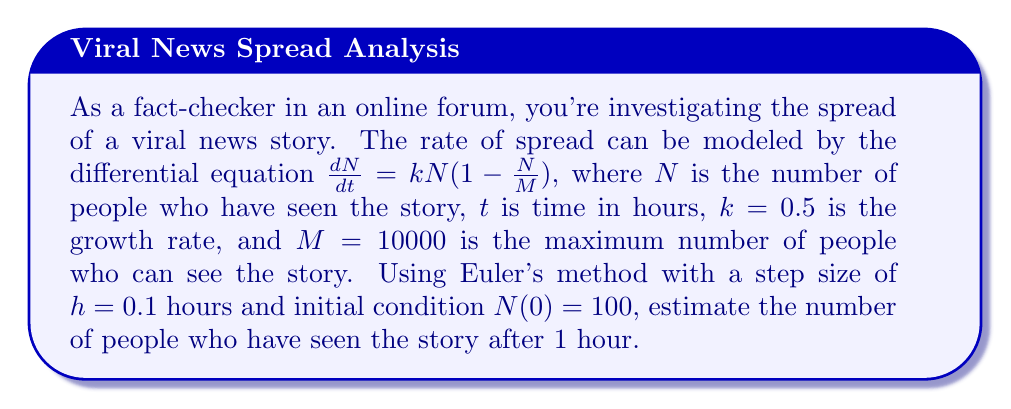Solve this math problem. To solve this problem using Euler's method, we follow these steps:

1) Euler's method is given by the formula:
   $$N_{i+1} = N_i + h \cdot f(t_i, N_i)$$
   where $f(t, N) = \frac{dN}{dt} = kN(1-\frac{N}{M})$

2) We're given:
   $k = 0.5$, $M = 10000$, $h = 0.1$, $N(0) = 100$, and we need to calculate up to $t = 1$ hour

3) The number of steps will be:
   $\text{steps} = \frac{1 \text{ hour}}{0.1 \text{ hour/step}} = 10 \text{ steps}$

4) Let's calculate the first few steps:

   For $i = 0$:
   $f(t_0, N_0) = 0.5 \cdot 100 \cdot (1-\frac{100}{10000}) = 49.5$
   $N_1 = 100 + 0.1 \cdot 49.5 = 104.95$

   For $i = 1$:
   $f(t_1, N_1) = 0.5 \cdot 104.95 \cdot (1-\frac{104.95}{10000}) = 51.8603$
   $N_2 = 104.95 + 0.1 \cdot 51.8603 = 110.1360$

5) We continue this process for 8 more steps. The final result after 10 steps (1 hour) is approximately 164.8720.
Answer: 164.87 people 